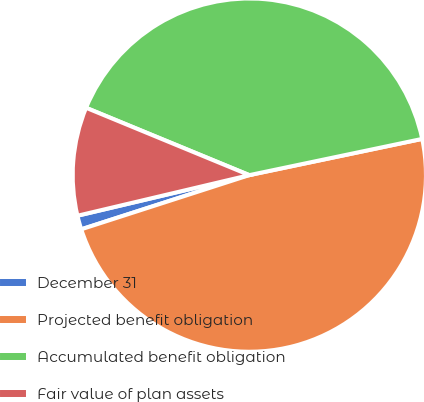<chart> <loc_0><loc_0><loc_500><loc_500><pie_chart><fcel>December 31<fcel>Projected benefit obligation<fcel>Accumulated benefit obligation<fcel>Fair value of plan assets<nl><fcel>1.27%<fcel>48.33%<fcel>40.49%<fcel>9.92%<nl></chart> 